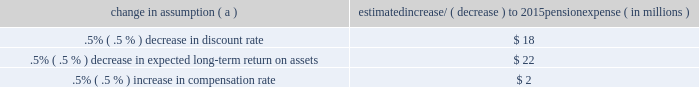The discount rate used to measure pension obligations is determined by comparing the expected future benefits that will be paid under the plan with yields available on high quality corporate bonds of similar duration .
The impact on pension expense of a .5% ( .5 % ) decrease in discount rate in the current environment is an increase of $ 18 million per year .
This sensitivity depends on the economic environment and amount of unrecognized actuarial gains or losses on the measurement date .
The expected long-term return on assets assumption also has a significant effect on pension expense .
The expected return on plan assets is a long-term assumption established by considering historical and anticipated returns of the asset classes invested in by the pension plan and the asset allocation policy currently in place .
For purposes of setting and reviewing this assumption , 201clong term 201d refers to the period over which the plan 2019s projected benefit obligations will be disbursed .
We review this assumption at each measurement date and adjust it if warranted .
Our selection process references certain historical data and the current environment , but primarily utilizes qualitative judgment regarding future return expectations .
To evaluate the continued reasonableness of our assumption , we examine a variety of viewpoints and data .
Various studies have shown that portfolios comprised primarily of u.s .
Equity securities have historically returned approximately 9% ( 9 % ) annually over long periods of time , while u.s .
Debt securities have returned approximately 6% ( 6 % ) annually over long periods .
Application of these historical returns to the plan 2019s allocation ranges for equities and bonds produces a result between 6.50% ( 6.50 % ) and 7.25% ( 7.25 % ) and is one point of reference , among many other factors , that is taken into consideration .
We also examine the plan 2019s actual historical returns over various periods and consider the current economic environment .
Recent experience is considered in our evaluation with appropriate consideration that , especially for short time periods , recent returns are not reliable indicators of future returns .
While annual returns can vary significantly ( actual returns for 2014 , 2013 and 2012 were +6.50% ( +6.50 % ) , +15.48% ( +15.48 % ) , and +15.29% ( +15.29 % ) , respectively ) , the selected assumption represents our estimated long-term average prospective returns .
Acknowledging the potentially wide range for this assumption , we also annually examine the assumption used by other companies with similar pension investment strategies , so that we can ascertain whether our determinations markedly differ from others .
In all cases , however , this data simply informs our process , which places the greatest emphasis on our qualitative judgment of future investment returns , given the conditions existing at each annual measurement date .
Taking into consideration all of these factors , the expected long-term return on plan assets for determining net periodic pension cost for 2014 was 7.00% ( 7.00 % ) , down from 7.50% ( 7.50 % ) for 2013 .
After considering the views of both internal and external capital market advisors , particularly with regard to the effects of the recent economic environment on long-term prospective fixed income returns , we are reducing our expected long-term return on assets to 6.75% ( 6.75 % ) for determining pension cost for under current accounting rules , the difference between expected long-term returns and actual returns is accumulated and amortized to pension expense over future periods .
Each one percentage point difference in actual return compared with our expected return can cause expense in subsequent years to increase or decrease by up to $ 9 million as the impact is amortized into results of operations .
We currently estimate pretax pension expense of $ 9 million in 2015 compared with pretax income of $ 7 million in 2014 .
This year-over-year expected increase in expense reflects the effects of the lower expected return on asset assumption , improved mortality , and the lower discount rate required to be used in 2015 .
These factors will be partially offset by the favorable impact of the increase in plan assets at december 31 , 2014 and the assumed return on a $ 200 million voluntary contribution to the plan made in february 2015 .
The table below reflects the estimated effects on pension expense of certain changes in annual assumptions , using 2015 estimated expense as a baseline .
Table 26 : pension expense 2013 sensitivity analysis change in assumption ( a ) estimated increase/ ( decrease ) to 2015 pension expense ( in millions ) .
( a ) the impact is the effect of changing the specified assumption while holding all other assumptions constant .
Our pension plan contribution requirements are not particularly sensitive to actuarial assumptions .
Investment performance has the most impact on contribution requirements and will drive the amount of required contributions in future years .
Also , current law , including the provisions of the pension protection act of 2006 , sets limits as to both minimum and maximum contributions to the plan .
Notwithstanding the voluntary contribution made in february 2015 noted above , we do not expect to be required to make any contributions to the plan during 2015 .
We maintain other defined benefit plans that have a less significant effect on financial results , including various nonqualified supplemental retirement plans for certain employees , which are described more fully in note 13 employee benefit plans in the notes to consolidated financial statements in item 8 of this report .
66 the pnc financial services group , inc .
2013 form 10-k .
What's the percentage increase from the 2014 estimated pretax pension expense with the expense for 2015? 
Computations: (((9 - 7) / 7) * 100)
Answer: 28.57143. 